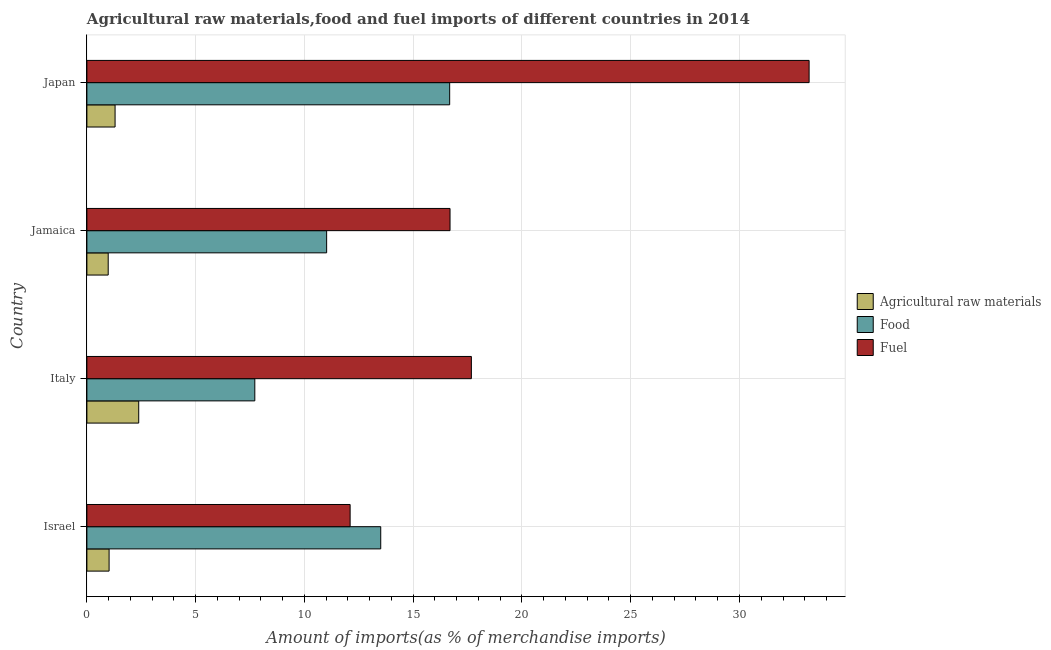Are the number of bars per tick equal to the number of legend labels?
Provide a short and direct response. Yes. Are the number of bars on each tick of the Y-axis equal?
Your answer should be very brief. Yes. How many bars are there on the 4th tick from the top?
Your answer should be very brief. 3. In how many cases, is the number of bars for a given country not equal to the number of legend labels?
Offer a terse response. 0. What is the percentage of raw materials imports in Jamaica?
Your response must be concise. 0.98. Across all countries, what is the maximum percentage of food imports?
Provide a succinct answer. 16.68. Across all countries, what is the minimum percentage of raw materials imports?
Ensure brevity in your answer.  0.98. In which country was the percentage of fuel imports minimum?
Keep it short and to the point. Israel. What is the total percentage of fuel imports in the graph?
Offer a very short reply. 79.67. What is the difference between the percentage of fuel imports in Jamaica and that in Japan?
Make the answer very short. -16.51. What is the difference between the percentage of raw materials imports in Jamaica and the percentage of fuel imports in Italy?
Offer a very short reply. -16.7. What is the average percentage of food imports per country?
Offer a terse response. 12.23. What is the difference between the percentage of raw materials imports and percentage of food imports in Italy?
Offer a very short reply. -5.34. In how many countries, is the percentage of fuel imports greater than 25 %?
Make the answer very short. 1. What is the ratio of the percentage of raw materials imports in Italy to that in Japan?
Provide a succinct answer. 1.84. What is the difference between the highest and the second highest percentage of food imports?
Provide a succinct answer. 3.17. What is the difference between the highest and the lowest percentage of food imports?
Offer a very short reply. 8.96. What does the 1st bar from the top in Israel represents?
Keep it short and to the point. Fuel. What does the 1st bar from the bottom in Italy represents?
Your answer should be very brief. Agricultural raw materials. Is it the case that in every country, the sum of the percentage of raw materials imports and percentage of food imports is greater than the percentage of fuel imports?
Your answer should be very brief. No. How many bars are there?
Provide a succinct answer. 12. What is the difference between two consecutive major ticks on the X-axis?
Ensure brevity in your answer.  5. Does the graph contain any zero values?
Make the answer very short. No. How are the legend labels stacked?
Give a very brief answer. Vertical. What is the title of the graph?
Offer a terse response. Agricultural raw materials,food and fuel imports of different countries in 2014. What is the label or title of the X-axis?
Give a very brief answer. Amount of imports(as % of merchandise imports). What is the Amount of imports(as % of merchandise imports) of Agricultural raw materials in Israel?
Provide a short and direct response. 1.02. What is the Amount of imports(as % of merchandise imports) of Food in Israel?
Your answer should be compact. 13.51. What is the Amount of imports(as % of merchandise imports) in Fuel in Israel?
Offer a terse response. 12.1. What is the Amount of imports(as % of merchandise imports) in Agricultural raw materials in Italy?
Keep it short and to the point. 2.38. What is the Amount of imports(as % of merchandise imports) in Food in Italy?
Offer a terse response. 7.72. What is the Amount of imports(as % of merchandise imports) of Fuel in Italy?
Your answer should be very brief. 17.67. What is the Amount of imports(as % of merchandise imports) in Agricultural raw materials in Jamaica?
Offer a very short reply. 0.98. What is the Amount of imports(as % of merchandise imports) of Food in Jamaica?
Your answer should be very brief. 11.02. What is the Amount of imports(as % of merchandise imports) in Fuel in Jamaica?
Your answer should be compact. 16.69. What is the Amount of imports(as % of merchandise imports) of Agricultural raw materials in Japan?
Your response must be concise. 1.3. What is the Amount of imports(as % of merchandise imports) of Food in Japan?
Offer a terse response. 16.68. What is the Amount of imports(as % of merchandise imports) in Fuel in Japan?
Your response must be concise. 33.2. Across all countries, what is the maximum Amount of imports(as % of merchandise imports) in Agricultural raw materials?
Keep it short and to the point. 2.38. Across all countries, what is the maximum Amount of imports(as % of merchandise imports) of Food?
Make the answer very short. 16.68. Across all countries, what is the maximum Amount of imports(as % of merchandise imports) in Fuel?
Your response must be concise. 33.2. Across all countries, what is the minimum Amount of imports(as % of merchandise imports) in Agricultural raw materials?
Offer a very short reply. 0.98. Across all countries, what is the minimum Amount of imports(as % of merchandise imports) in Food?
Keep it short and to the point. 7.72. Across all countries, what is the minimum Amount of imports(as % of merchandise imports) in Fuel?
Offer a very short reply. 12.1. What is the total Amount of imports(as % of merchandise imports) in Agricultural raw materials in the graph?
Your answer should be very brief. 5.68. What is the total Amount of imports(as % of merchandise imports) of Food in the graph?
Your answer should be very brief. 48.92. What is the total Amount of imports(as % of merchandise imports) of Fuel in the graph?
Your answer should be very brief. 79.67. What is the difference between the Amount of imports(as % of merchandise imports) of Agricultural raw materials in Israel and that in Italy?
Keep it short and to the point. -1.36. What is the difference between the Amount of imports(as % of merchandise imports) of Food in Israel and that in Italy?
Provide a succinct answer. 5.79. What is the difference between the Amount of imports(as % of merchandise imports) in Fuel in Israel and that in Italy?
Offer a terse response. -5.57. What is the difference between the Amount of imports(as % of merchandise imports) of Agricultural raw materials in Israel and that in Jamaica?
Your response must be concise. 0.04. What is the difference between the Amount of imports(as % of merchandise imports) of Food in Israel and that in Jamaica?
Make the answer very short. 2.49. What is the difference between the Amount of imports(as % of merchandise imports) of Fuel in Israel and that in Jamaica?
Provide a short and direct response. -4.59. What is the difference between the Amount of imports(as % of merchandise imports) in Agricultural raw materials in Israel and that in Japan?
Your answer should be very brief. -0.27. What is the difference between the Amount of imports(as % of merchandise imports) of Food in Israel and that in Japan?
Your response must be concise. -3.17. What is the difference between the Amount of imports(as % of merchandise imports) of Fuel in Israel and that in Japan?
Your answer should be compact. -21.1. What is the difference between the Amount of imports(as % of merchandise imports) in Agricultural raw materials in Italy and that in Jamaica?
Give a very brief answer. 1.4. What is the difference between the Amount of imports(as % of merchandise imports) of Food in Italy and that in Jamaica?
Your answer should be very brief. -3.3. What is the difference between the Amount of imports(as % of merchandise imports) of Fuel in Italy and that in Jamaica?
Provide a short and direct response. 0.98. What is the difference between the Amount of imports(as % of merchandise imports) of Agricultural raw materials in Italy and that in Japan?
Offer a very short reply. 1.09. What is the difference between the Amount of imports(as % of merchandise imports) of Food in Italy and that in Japan?
Offer a terse response. -8.96. What is the difference between the Amount of imports(as % of merchandise imports) in Fuel in Italy and that in Japan?
Offer a terse response. -15.53. What is the difference between the Amount of imports(as % of merchandise imports) in Agricultural raw materials in Jamaica and that in Japan?
Provide a succinct answer. -0.32. What is the difference between the Amount of imports(as % of merchandise imports) in Food in Jamaica and that in Japan?
Your answer should be very brief. -5.66. What is the difference between the Amount of imports(as % of merchandise imports) in Fuel in Jamaica and that in Japan?
Offer a very short reply. -16.51. What is the difference between the Amount of imports(as % of merchandise imports) in Agricultural raw materials in Israel and the Amount of imports(as % of merchandise imports) in Food in Italy?
Offer a very short reply. -6.7. What is the difference between the Amount of imports(as % of merchandise imports) of Agricultural raw materials in Israel and the Amount of imports(as % of merchandise imports) of Fuel in Italy?
Offer a very short reply. -16.65. What is the difference between the Amount of imports(as % of merchandise imports) of Food in Israel and the Amount of imports(as % of merchandise imports) of Fuel in Italy?
Ensure brevity in your answer.  -4.17. What is the difference between the Amount of imports(as % of merchandise imports) in Agricultural raw materials in Israel and the Amount of imports(as % of merchandise imports) in Food in Jamaica?
Give a very brief answer. -10. What is the difference between the Amount of imports(as % of merchandise imports) in Agricultural raw materials in Israel and the Amount of imports(as % of merchandise imports) in Fuel in Jamaica?
Your answer should be very brief. -15.67. What is the difference between the Amount of imports(as % of merchandise imports) of Food in Israel and the Amount of imports(as % of merchandise imports) of Fuel in Jamaica?
Give a very brief answer. -3.19. What is the difference between the Amount of imports(as % of merchandise imports) of Agricultural raw materials in Israel and the Amount of imports(as % of merchandise imports) of Food in Japan?
Offer a very short reply. -15.66. What is the difference between the Amount of imports(as % of merchandise imports) in Agricultural raw materials in Israel and the Amount of imports(as % of merchandise imports) in Fuel in Japan?
Make the answer very short. -32.18. What is the difference between the Amount of imports(as % of merchandise imports) of Food in Israel and the Amount of imports(as % of merchandise imports) of Fuel in Japan?
Offer a terse response. -19.69. What is the difference between the Amount of imports(as % of merchandise imports) in Agricultural raw materials in Italy and the Amount of imports(as % of merchandise imports) in Food in Jamaica?
Offer a terse response. -8.64. What is the difference between the Amount of imports(as % of merchandise imports) in Agricultural raw materials in Italy and the Amount of imports(as % of merchandise imports) in Fuel in Jamaica?
Ensure brevity in your answer.  -14.31. What is the difference between the Amount of imports(as % of merchandise imports) of Food in Italy and the Amount of imports(as % of merchandise imports) of Fuel in Jamaica?
Provide a short and direct response. -8.97. What is the difference between the Amount of imports(as % of merchandise imports) of Agricultural raw materials in Italy and the Amount of imports(as % of merchandise imports) of Food in Japan?
Ensure brevity in your answer.  -14.29. What is the difference between the Amount of imports(as % of merchandise imports) of Agricultural raw materials in Italy and the Amount of imports(as % of merchandise imports) of Fuel in Japan?
Give a very brief answer. -30.82. What is the difference between the Amount of imports(as % of merchandise imports) of Food in Italy and the Amount of imports(as % of merchandise imports) of Fuel in Japan?
Ensure brevity in your answer.  -25.48. What is the difference between the Amount of imports(as % of merchandise imports) in Agricultural raw materials in Jamaica and the Amount of imports(as % of merchandise imports) in Food in Japan?
Your answer should be very brief. -15.7. What is the difference between the Amount of imports(as % of merchandise imports) of Agricultural raw materials in Jamaica and the Amount of imports(as % of merchandise imports) of Fuel in Japan?
Offer a very short reply. -32.22. What is the difference between the Amount of imports(as % of merchandise imports) of Food in Jamaica and the Amount of imports(as % of merchandise imports) of Fuel in Japan?
Give a very brief answer. -22.18. What is the average Amount of imports(as % of merchandise imports) of Agricultural raw materials per country?
Give a very brief answer. 1.42. What is the average Amount of imports(as % of merchandise imports) in Food per country?
Your response must be concise. 12.23. What is the average Amount of imports(as % of merchandise imports) of Fuel per country?
Your answer should be very brief. 19.92. What is the difference between the Amount of imports(as % of merchandise imports) in Agricultural raw materials and Amount of imports(as % of merchandise imports) in Food in Israel?
Keep it short and to the point. -12.49. What is the difference between the Amount of imports(as % of merchandise imports) of Agricultural raw materials and Amount of imports(as % of merchandise imports) of Fuel in Israel?
Make the answer very short. -11.08. What is the difference between the Amount of imports(as % of merchandise imports) of Food and Amount of imports(as % of merchandise imports) of Fuel in Israel?
Your response must be concise. 1.41. What is the difference between the Amount of imports(as % of merchandise imports) of Agricultural raw materials and Amount of imports(as % of merchandise imports) of Food in Italy?
Keep it short and to the point. -5.34. What is the difference between the Amount of imports(as % of merchandise imports) of Agricultural raw materials and Amount of imports(as % of merchandise imports) of Fuel in Italy?
Provide a short and direct response. -15.29. What is the difference between the Amount of imports(as % of merchandise imports) of Food and Amount of imports(as % of merchandise imports) of Fuel in Italy?
Offer a terse response. -9.96. What is the difference between the Amount of imports(as % of merchandise imports) in Agricultural raw materials and Amount of imports(as % of merchandise imports) in Food in Jamaica?
Provide a short and direct response. -10.04. What is the difference between the Amount of imports(as % of merchandise imports) of Agricultural raw materials and Amount of imports(as % of merchandise imports) of Fuel in Jamaica?
Your response must be concise. -15.71. What is the difference between the Amount of imports(as % of merchandise imports) in Food and Amount of imports(as % of merchandise imports) in Fuel in Jamaica?
Your answer should be very brief. -5.67. What is the difference between the Amount of imports(as % of merchandise imports) of Agricultural raw materials and Amount of imports(as % of merchandise imports) of Food in Japan?
Provide a succinct answer. -15.38. What is the difference between the Amount of imports(as % of merchandise imports) in Agricultural raw materials and Amount of imports(as % of merchandise imports) in Fuel in Japan?
Your answer should be very brief. -31.91. What is the difference between the Amount of imports(as % of merchandise imports) of Food and Amount of imports(as % of merchandise imports) of Fuel in Japan?
Your answer should be very brief. -16.52. What is the ratio of the Amount of imports(as % of merchandise imports) in Agricultural raw materials in Israel to that in Italy?
Offer a very short reply. 0.43. What is the ratio of the Amount of imports(as % of merchandise imports) of Food in Israel to that in Italy?
Provide a succinct answer. 1.75. What is the ratio of the Amount of imports(as % of merchandise imports) of Fuel in Israel to that in Italy?
Make the answer very short. 0.68. What is the ratio of the Amount of imports(as % of merchandise imports) in Agricultural raw materials in Israel to that in Jamaica?
Provide a succinct answer. 1.04. What is the ratio of the Amount of imports(as % of merchandise imports) in Food in Israel to that in Jamaica?
Your response must be concise. 1.23. What is the ratio of the Amount of imports(as % of merchandise imports) of Fuel in Israel to that in Jamaica?
Offer a terse response. 0.72. What is the ratio of the Amount of imports(as % of merchandise imports) in Agricultural raw materials in Israel to that in Japan?
Keep it short and to the point. 0.79. What is the ratio of the Amount of imports(as % of merchandise imports) of Food in Israel to that in Japan?
Offer a terse response. 0.81. What is the ratio of the Amount of imports(as % of merchandise imports) in Fuel in Israel to that in Japan?
Your answer should be very brief. 0.36. What is the ratio of the Amount of imports(as % of merchandise imports) in Agricultural raw materials in Italy to that in Jamaica?
Provide a short and direct response. 2.43. What is the ratio of the Amount of imports(as % of merchandise imports) of Food in Italy to that in Jamaica?
Offer a very short reply. 0.7. What is the ratio of the Amount of imports(as % of merchandise imports) in Fuel in Italy to that in Jamaica?
Offer a very short reply. 1.06. What is the ratio of the Amount of imports(as % of merchandise imports) in Agricultural raw materials in Italy to that in Japan?
Provide a succinct answer. 1.84. What is the ratio of the Amount of imports(as % of merchandise imports) in Food in Italy to that in Japan?
Make the answer very short. 0.46. What is the ratio of the Amount of imports(as % of merchandise imports) in Fuel in Italy to that in Japan?
Provide a succinct answer. 0.53. What is the ratio of the Amount of imports(as % of merchandise imports) in Agricultural raw materials in Jamaica to that in Japan?
Ensure brevity in your answer.  0.76. What is the ratio of the Amount of imports(as % of merchandise imports) of Food in Jamaica to that in Japan?
Keep it short and to the point. 0.66. What is the ratio of the Amount of imports(as % of merchandise imports) of Fuel in Jamaica to that in Japan?
Your response must be concise. 0.5. What is the difference between the highest and the second highest Amount of imports(as % of merchandise imports) of Agricultural raw materials?
Your answer should be very brief. 1.09. What is the difference between the highest and the second highest Amount of imports(as % of merchandise imports) of Food?
Provide a short and direct response. 3.17. What is the difference between the highest and the second highest Amount of imports(as % of merchandise imports) of Fuel?
Offer a terse response. 15.53. What is the difference between the highest and the lowest Amount of imports(as % of merchandise imports) in Agricultural raw materials?
Your response must be concise. 1.4. What is the difference between the highest and the lowest Amount of imports(as % of merchandise imports) of Food?
Your answer should be very brief. 8.96. What is the difference between the highest and the lowest Amount of imports(as % of merchandise imports) in Fuel?
Your answer should be compact. 21.1. 